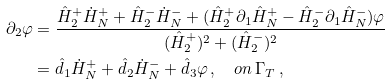Convert formula to latex. <formula><loc_0><loc_0><loc_500><loc_500>\partial _ { 2 } \varphi & = \frac { \hat { H } ^ { + } _ { 2 } \dot { H } ^ { + } _ { N } + \hat { H } ^ { - } _ { 2 } \dot { H } ^ { - } _ { N } + ( \hat { H } ^ { + } _ { 2 } \partial _ { 1 } \hat { H } ^ { + } _ { N } - \hat { H } ^ { - } _ { 2 } \partial _ { 1 } \hat { H } ^ { - } _ { N } ) \varphi } { ( \hat { H } ^ { + } _ { 2 } ) ^ { 2 } + ( \hat { H } ^ { - } _ { 2 } ) ^ { 2 } } \\ & = \hat { d } _ { 1 } \dot { H } ^ { + } _ { N } + \hat { d } _ { 2 } \dot { H } ^ { - } _ { N } + \hat { d } _ { 3 } \varphi \, , \quad o n \, \Gamma _ { T } \, ,</formula> 